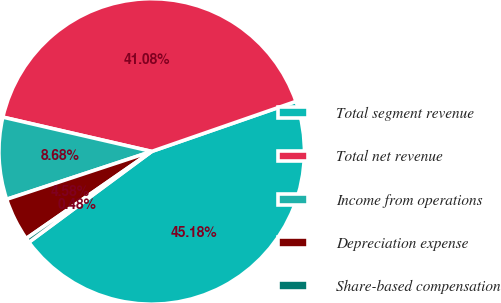Convert chart to OTSL. <chart><loc_0><loc_0><loc_500><loc_500><pie_chart><fcel>Total segment revenue<fcel>Total net revenue<fcel>Income from operations<fcel>Depreciation expense<fcel>Share-based compensation<nl><fcel>45.18%<fcel>41.08%<fcel>8.68%<fcel>4.58%<fcel>0.48%<nl></chart> 